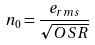<formula> <loc_0><loc_0><loc_500><loc_500>n _ { 0 } = \frac { e _ { r m s } } { \sqrt { O S R } }</formula> 